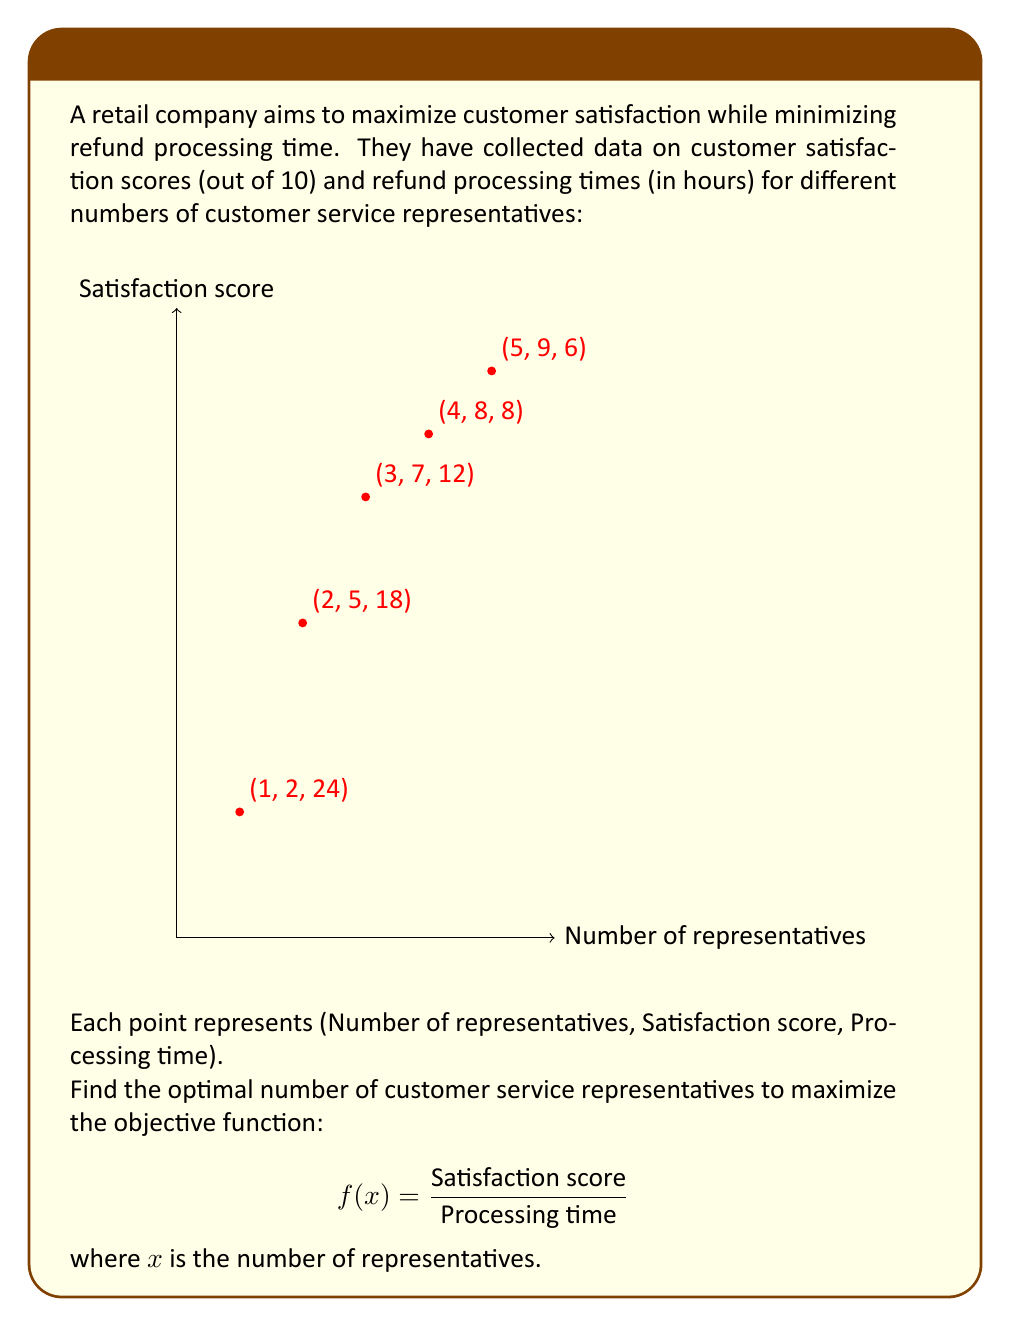Give your solution to this math problem. Let's approach this step-by-step:

1) First, we need to calculate the objective function value for each data point:

   For 1 representative: $f(1) = \frac{2}{24} = 0.083$
   For 2 representatives: $f(2) = \frac{5}{18} = 0.278$
   For 3 representatives: $f(3) = \frac{7}{12} = 0.583$
   For 4 representatives: $f(4) = \frac{8}{8} = 1.000$
   For 5 representatives: $f(5) = \frac{9}{6} = 1.500$

2) We can see that the objective function value increases as the number of representatives increases. This makes sense because:
   - Satisfaction scores are increasing
   - Processing times are decreasing

3) The highest value of the objective function is achieved with 5 representatives:

   $f(5) = 1.500$

4) This result suggests that having more representatives leads to better outcomes in terms of balancing satisfaction and processing time.

5) However, it's important to note that this analysis doesn't consider other factors like cost of hiring representatives or diminishing returns beyond 5 representatives.
Answer: 5 representatives 